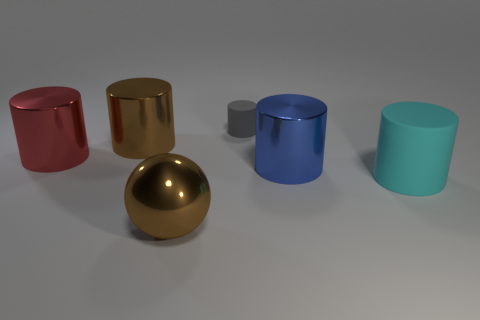Add 2 cylinders. How many objects exist? 8 Subtract all large red cylinders. How many cylinders are left? 4 Subtract 5 cylinders. How many cylinders are left? 0 Subtract 1 brown cylinders. How many objects are left? 5 Subtract all spheres. How many objects are left? 5 Subtract all purple spheres. Subtract all red cubes. How many spheres are left? 1 Subtract all yellow balls. How many green cylinders are left? 0 Subtract all shiny objects. Subtract all blue cylinders. How many objects are left? 1 Add 1 large red things. How many large red things are left? 2 Add 6 blue things. How many blue things exist? 7 